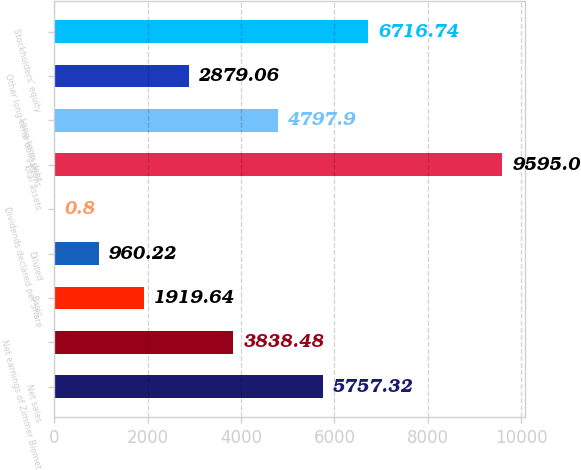<chart> <loc_0><loc_0><loc_500><loc_500><bar_chart><fcel>Net sales<fcel>Net earnings of Zimmer Biomet<fcel>Basic<fcel>Diluted<fcel>Dividends declared per share<fcel>Total assets<fcel>Long-term debt<fcel>Other long-term obligations<fcel>Stockholders' equity<nl><fcel>5757.32<fcel>3838.48<fcel>1919.64<fcel>960.22<fcel>0.8<fcel>9595<fcel>4797.9<fcel>2879.06<fcel>6716.74<nl></chart> 